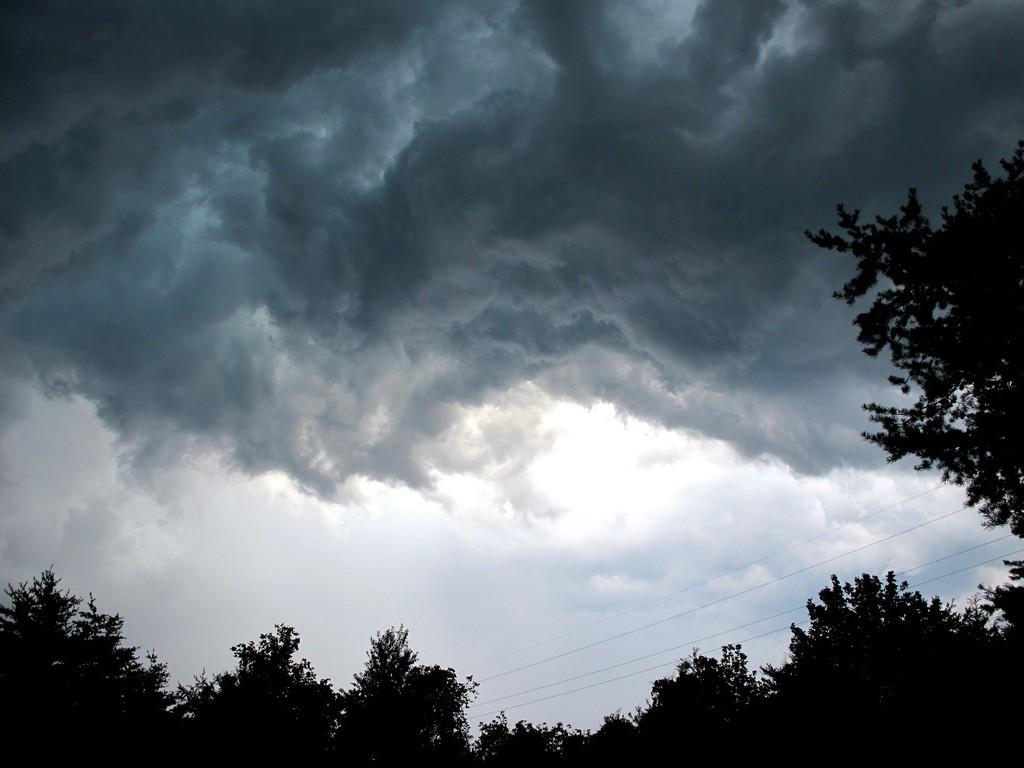Can you describe this image briefly? In this image we can see sky, clouds, wires and trees. 